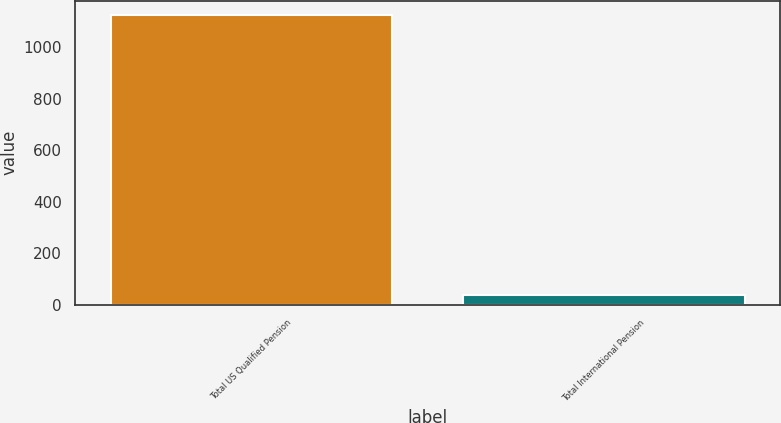<chart> <loc_0><loc_0><loc_500><loc_500><bar_chart><fcel>Total US Qualified Pension<fcel>Total International Pension<nl><fcel>1124.8<fcel>37.8<nl></chart> 